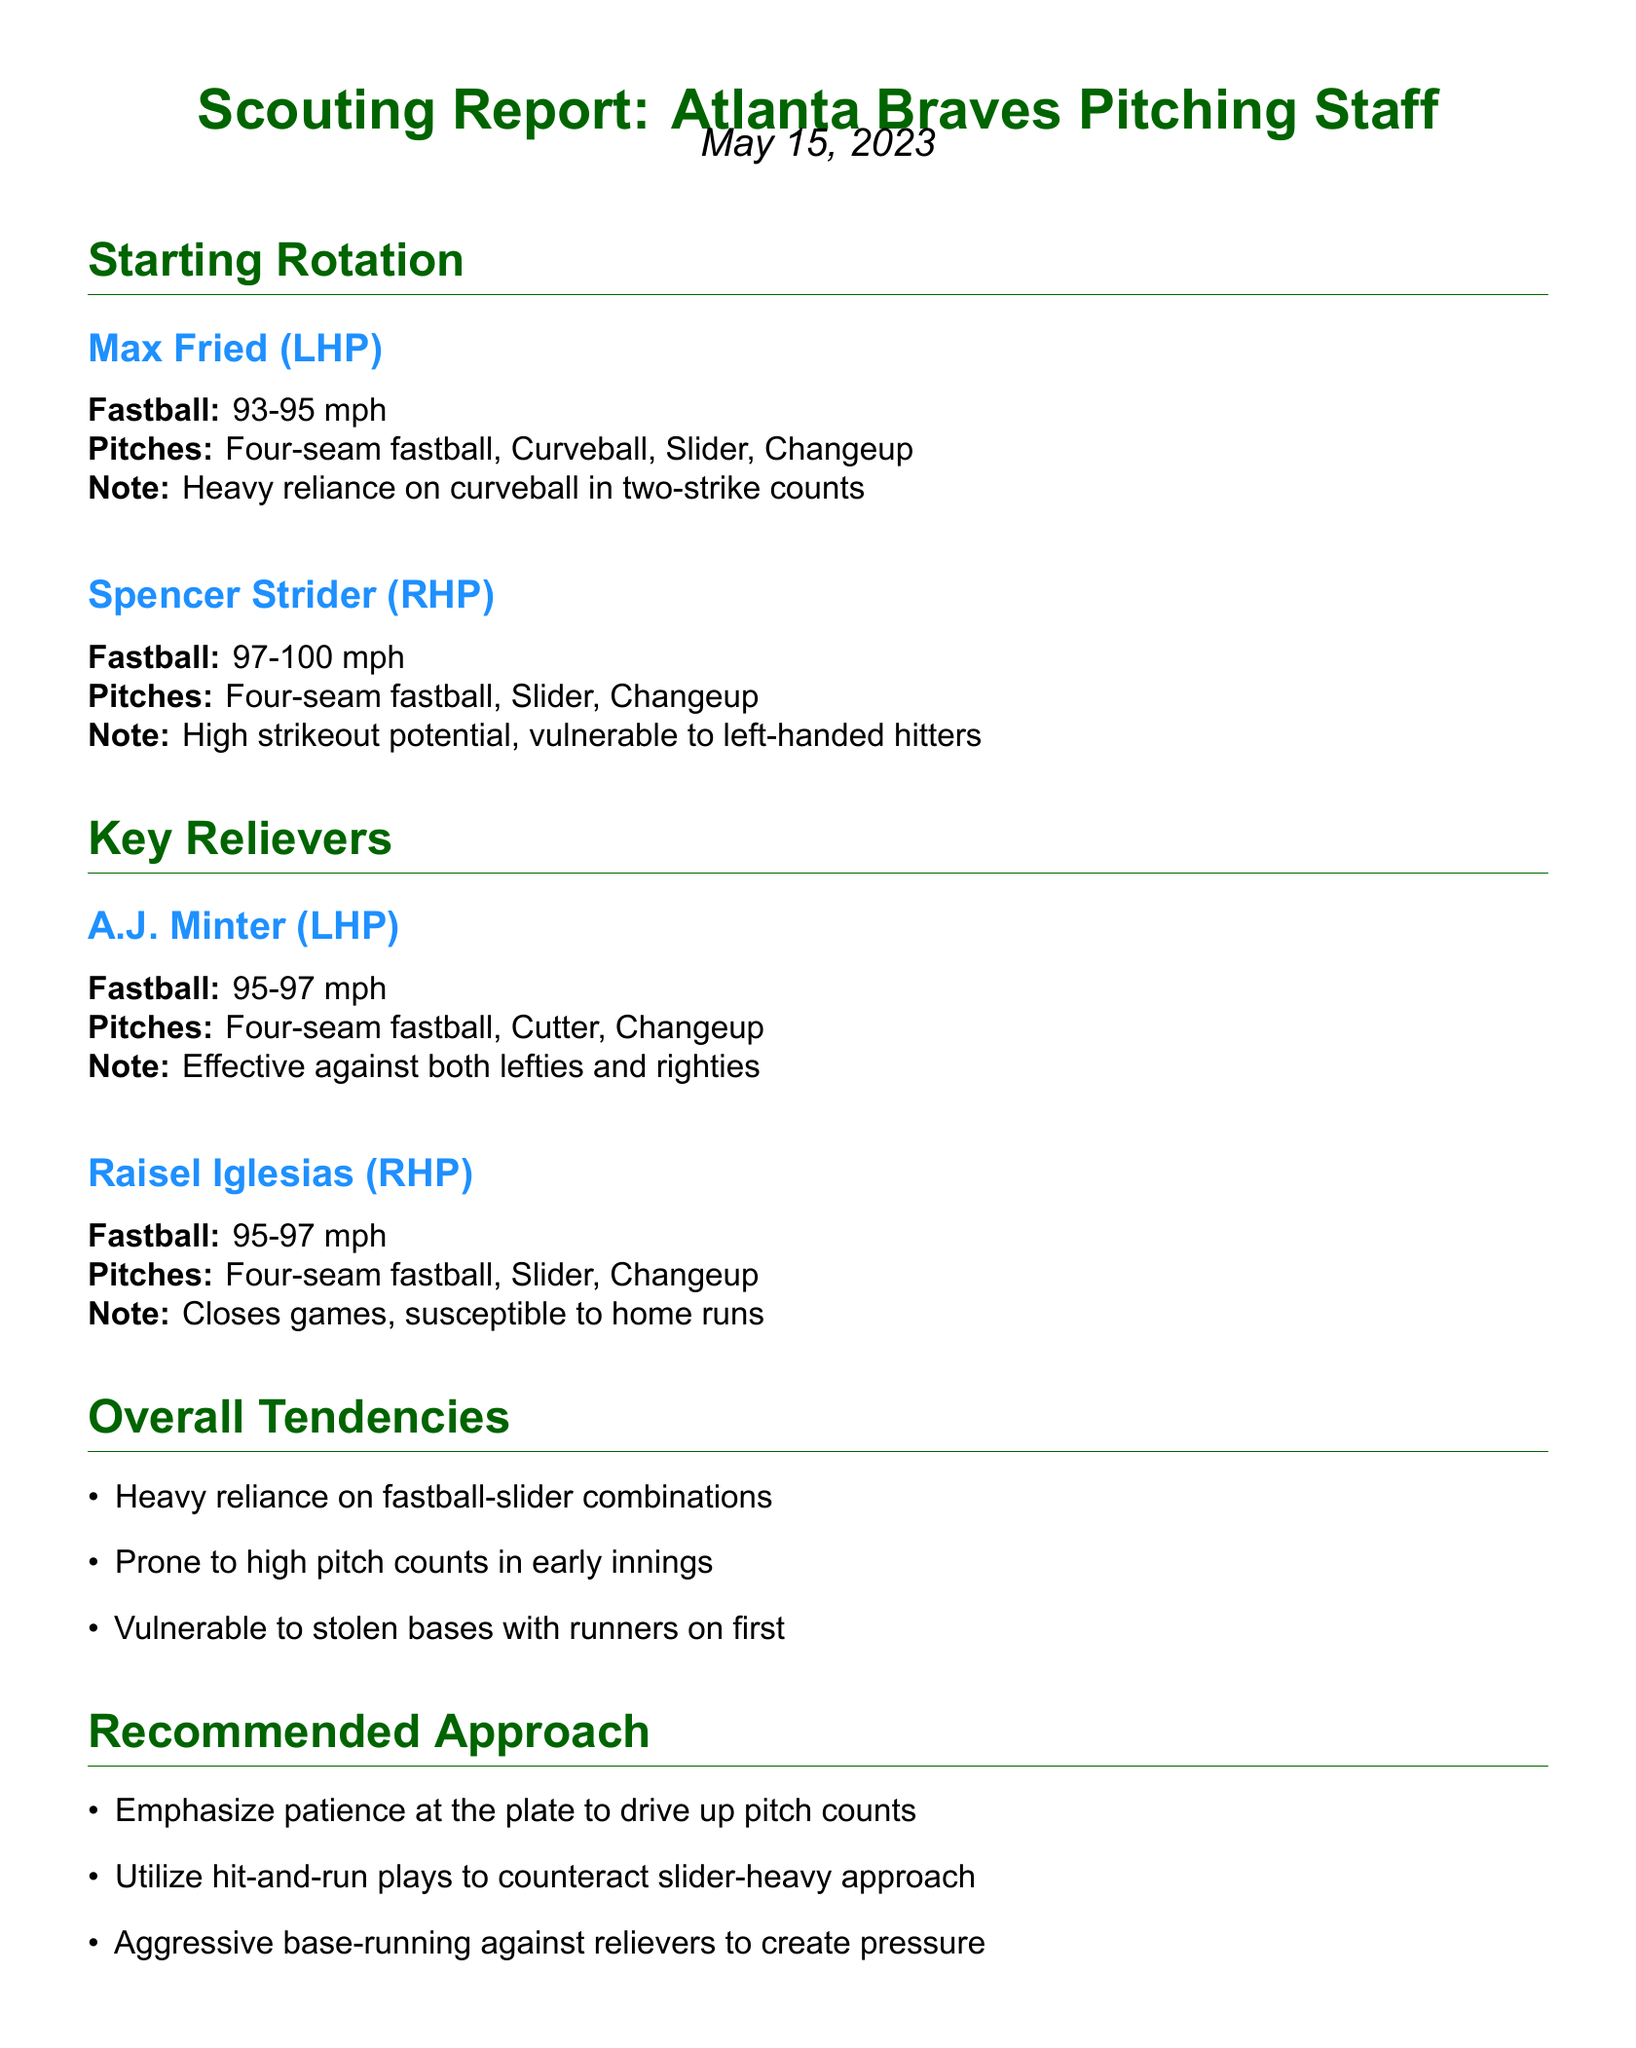What is the fastball velocity of Max Fried? The fastball velocity for Max Fried is specified in the document as ranging from 93 to 95 mph.
Answer: 93-95 mph What type of pitch does Spencer Strider heavily rely on? The document notes that Spencer Strider has a high strikeout potential but is vulnerable to left-handed hitters, indicating an area of focus in pitch type.
Answer: Slider Who closes games for the Atlanta Braves? The document states that Raisel Iglesias is the player who closes games for the team.
Answer: Raisel Iglesias What is A.J. Minter's maximum fastball speed? The maximum fastball speed for A.J. Minter, according to the document, is 97 mph.
Answer: 97 mph What is mentioned about the team's pitch counts? The document notes that the pitching staff is prone to high pitch counts in early innings.
Answer: High pitch counts in early innings Which approach is recommended against the relievers? One of the recommended approaches in the document suggests utilizing aggressive base-running against the relievers.
Answer: Aggressive base-running How many pitches does Max Fried throw? The document lists four types of pitches that Max Fried employs.
Answer: Four What is a noted vulnerability of Raisel Iglesias? The document indicates that Raisel Iglesias is susceptible to home runs.
Answer: Susceptible to home runs What should be emphasized at the plate according to the recommended approach? The document recommends emphasizing patience at the plate to drive up pitch counts.
Answer: Patience at the plate 